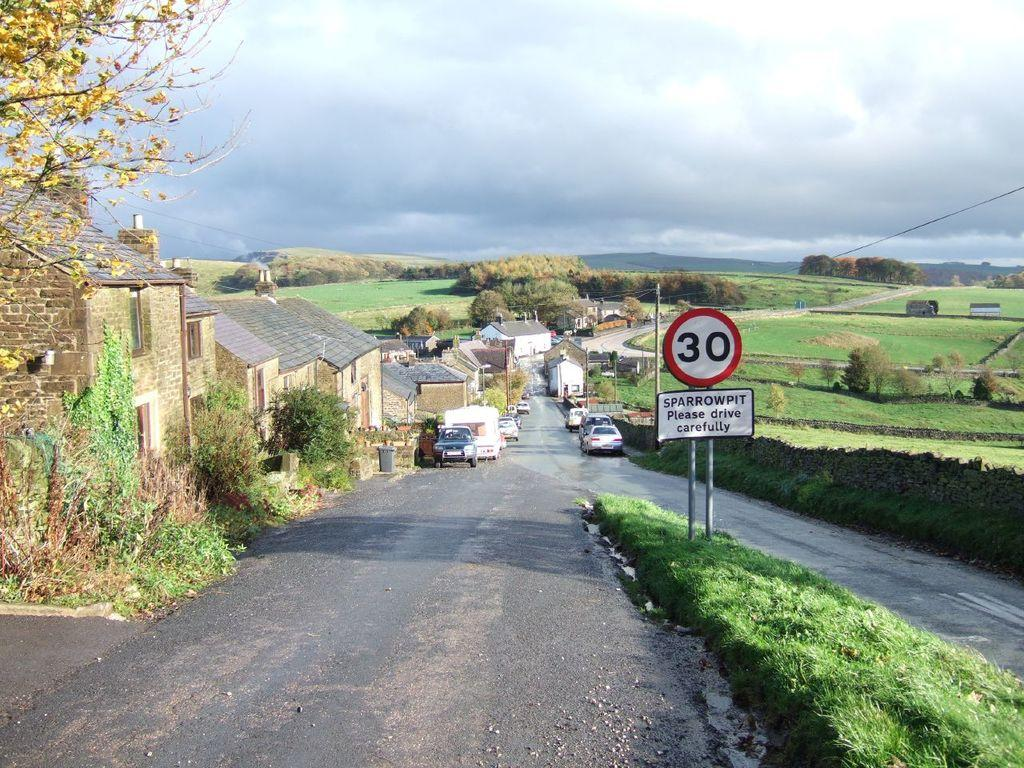<image>
Render a clear and concise summary of the photo. a sign on the side of a small road says please drive carefully. 